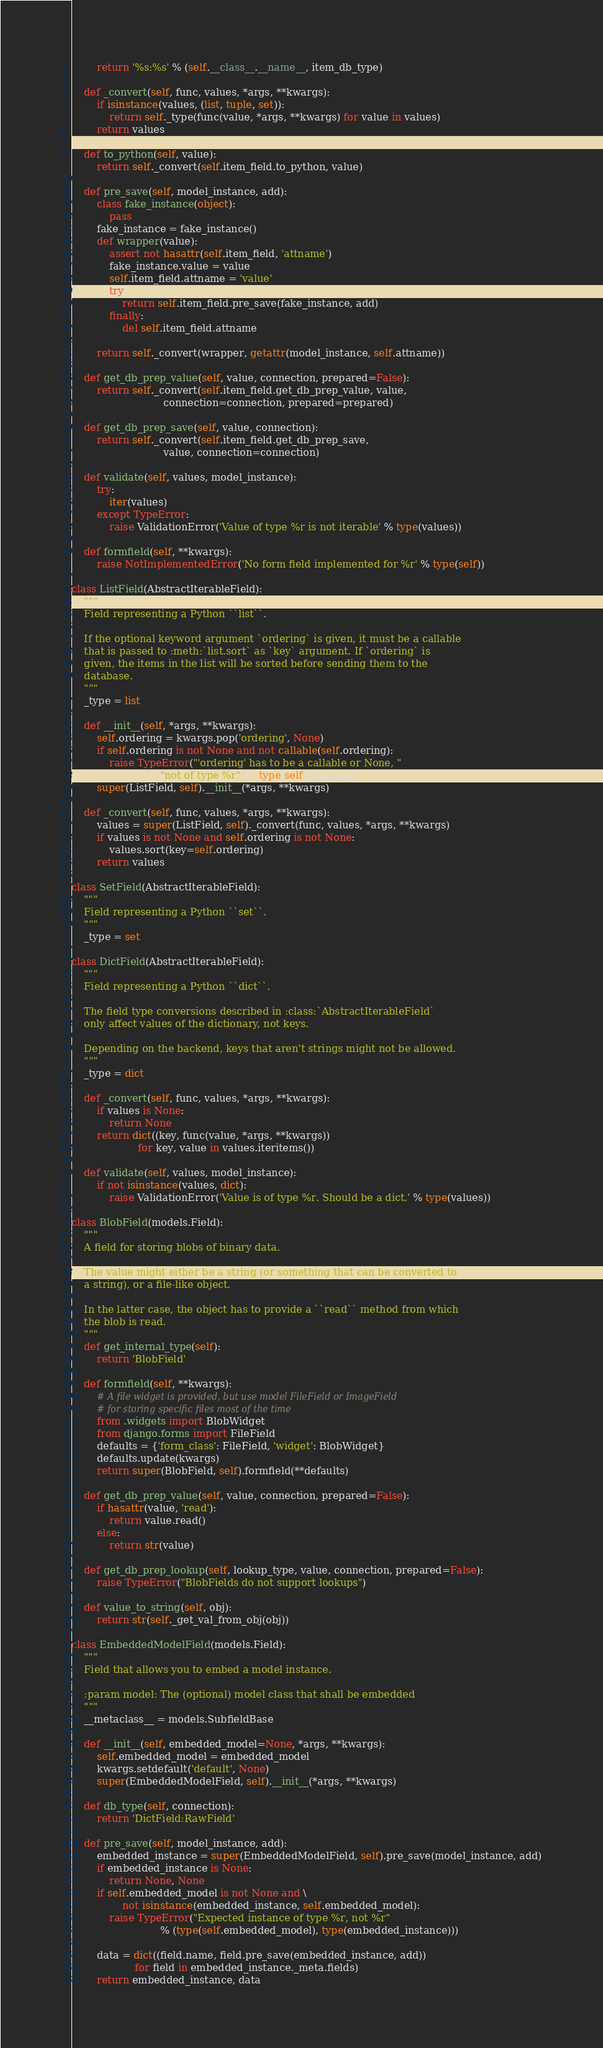Convert code to text. <code><loc_0><loc_0><loc_500><loc_500><_Python_>        return '%s:%s' % (self.__class__.__name__, item_db_type)

    def _convert(self, func, values, *args, **kwargs):
        if isinstance(values, (list, tuple, set)):
            return self._type(func(value, *args, **kwargs) for value in values)
        return values

    def to_python(self, value):
        return self._convert(self.item_field.to_python, value)

    def pre_save(self, model_instance, add):
        class fake_instance(object):
            pass
        fake_instance = fake_instance()
        def wrapper(value):
            assert not hasattr(self.item_field, 'attname')
            fake_instance.value = value
            self.item_field.attname = 'value'
            try:
                return self.item_field.pre_save(fake_instance, add)
            finally:
                del self.item_field.attname

        return self._convert(wrapper, getattr(model_instance, self.attname))

    def get_db_prep_value(self, value, connection, prepared=False):
        return self._convert(self.item_field.get_db_prep_value, value,
                             connection=connection, prepared=prepared)

    def get_db_prep_save(self, value, connection):
        return self._convert(self.item_field.get_db_prep_save,
                             value, connection=connection)

    def validate(self, values, model_instance):
        try:
            iter(values)
        except TypeError:
            raise ValidationError('Value of type %r is not iterable' % type(values))

    def formfield(self, **kwargs):
        raise NotImplementedError('No form field implemented for %r' % type(self))

class ListField(AbstractIterableField):
    """
    Field representing a Python ``list``.

    If the optional keyword argument `ordering` is given, it must be a callable
    that is passed to :meth:`list.sort` as `key` argument. If `ordering` is
    given, the items in the list will be sorted before sending them to the
    database.
    """
    _type = list

    def __init__(self, *args, **kwargs):
        self.ordering = kwargs.pop('ordering', None)
        if self.ordering is not None and not callable(self.ordering):
            raise TypeError("'ordering' has to be a callable or None, "
                            "not of type %r" %  type(self.ordering))
        super(ListField, self).__init__(*args, **kwargs)

    def _convert(self, func, values, *args, **kwargs):
        values = super(ListField, self)._convert(func, values, *args, **kwargs)
        if values is not None and self.ordering is not None:
            values.sort(key=self.ordering)
        return values

class SetField(AbstractIterableField):
    """
    Field representing a Python ``set``.
    """
    _type = set

class DictField(AbstractIterableField):
    """
    Field representing a Python ``dict``.

    The field type conversions described in :class:`AbstractIterableField`
    only affect values of the dictionary, not keys.

    Depending on the backend, keys that aren't strings might not be allowed.
    """
    _type = dict

    def _convert(self, func, values, *args, **kwargs):
        if values is None:
            return None
        return dict((key, func(value, *args, **kwargs))
                     for key, value in values.iteritems())

    def validate(self, values, model_instance):
        if not isinstance(values, dict):
            raise ValidationError('Value is of type %r. Should be a dict.' % type(values))

class BlobField(models.Field):
    """
    A field for storing blobs of binary data.

    The value might either be a string (or something that can be converted to
    a string), or a file-like object.

    In the latter case, the object has to provide a ``read`` method from which
    the blob is read.
    """
    def get_internal_type(self):
        return 'BlobField'

    def formfield(self, **kwargs):
        # A file widget is provided, but use model FileField or ImageField
        # for storing specific files most of the time
        from .widgets import BlobWidget
        from django.forms import FileField
        defaults = {'form_class': FileField, 'widget': BlobWidget}
        defaults.update(kwargs)
        return super(BlobField, self).formfield(**defaults)

    def get_db_prep_value(self, value, connection, prepared=False):
        if hasattr(value, 'read'):
            return value.read()
        else:
            return str(value)

    def get_db_prep_lookup(self, lookup_type, value, connection, prepared=False):
        raise TypeError("BlobFields do not support lookups")

    def value_to_string(self, obj):
        return str(self._get_val_from_obj(obj))

class EmbeddedModelField(models.Field):
    """
    Field that allows you to embed a model instance.

    :param model: The (optional) model class that shall be embedded
    """
    __metaclass__ = models.SubfieldBase

    def __init__(self, embedded_model=None, *args, **kwargs):
        self.embedded_model = embedded_model
        kwargs.setdefault('default', None)
        super(EmbeddedModelField, self).__init__(*args, **kwargs)

    def db_type(self, connection):
        return 'DictField:RawField'

    def pre_save(self, model_instance, add):
        embedded_instance = super(EmbeddedModelField, self).pre_save(model_instance, add)
        if embedded_instance is None:
            return None, None
        if self.embedded_model is not None and \
                not isinstance(embedded_instance, self.embedded_model):
            raise TypeError("Expected instance of type %r, not %r"
                            % (type(self.embedded_model), type(embedded_instance)))

        data = dict((field.name, field.pre_save(embedded_instance, add))
                    for field in embedded_instance._meta.fields)
        return embedded_instance, data
</code> 